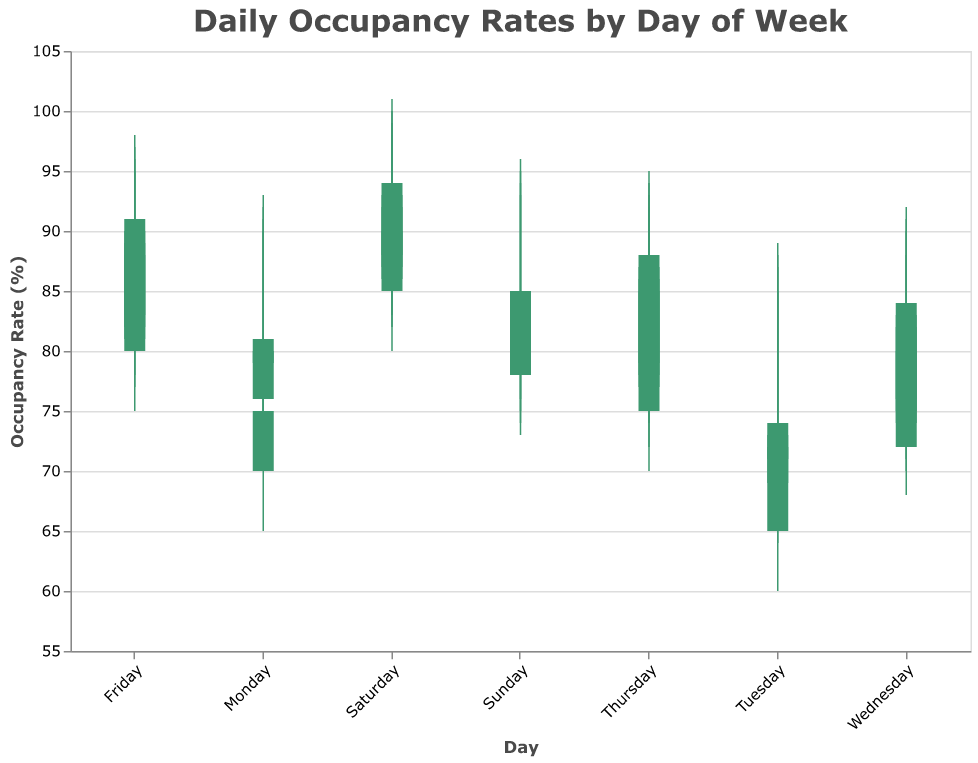What's the title of the plot? The title is typically positioned at the top of the plot. For this plot, it is clearly displayed at the top in a larger font size.
Answer: Daily Occupancy Rates by Day of Week What’s the highest occupancy rate recorded on a Saturday? On a candlestick plot, the highest value recorded is represented by the top of the upper wick. For Saturdays, the highest value reaches 101%.
Answer: 101% Which day of the week has the lowest opening occupancy rate? The opening occupancy rate is represented by the bottom of the body of each candlestick. By comparing the lowest values, it is apparent that Tuesday has the lowest opening rate at 65%.
Answer: Tuesday On which day is the occupancy rate most volatile, and what is the volatility range? Volatility can be gauged by the range between the highest and lowest values for a specific day. Saturday has the largest range, with values ranging from 80% to 101%, indicating a range of 21%.
Answer: Saturday, 21% Which day has the smallest difference between opening and closing rates? To find the smallest difference, calculate the difference between the opening and closing rates for each day and compare. Monday has the smallest difference, with values changing from 70% to 75%, a difference of 5%.
Answer: Monday, 5% What is the average closing occupancy rate for all days of the week? Calculate the average of all closing rates by summing them up and dividing by the number of days (28 data points). The total closing rates are 2234%, so the average is 2234/28 = 79.8%.
Answer: 79.8% Which day has consistently high occupancy rates but does not peak at the highest value? A consistent high rate means both opening and closing values are generally high, but does not reach the max value. Thursday fits this description with high values but not the highest peak.
Answer: Thursday How often does the closing rate exceed the opening rate throughout the week? Compare the opening and closing rates for each day to see how many times the closing rate is higher. This occurs on 14 instances.
Answer: 14 times Which day has the greatest difference between its highest and lowest values? By examining the full range (high minus low), Saturday shows the greatest difference, ranging from 101% to 85%, a difference of 16%.
Answer: Saturday, 16% 